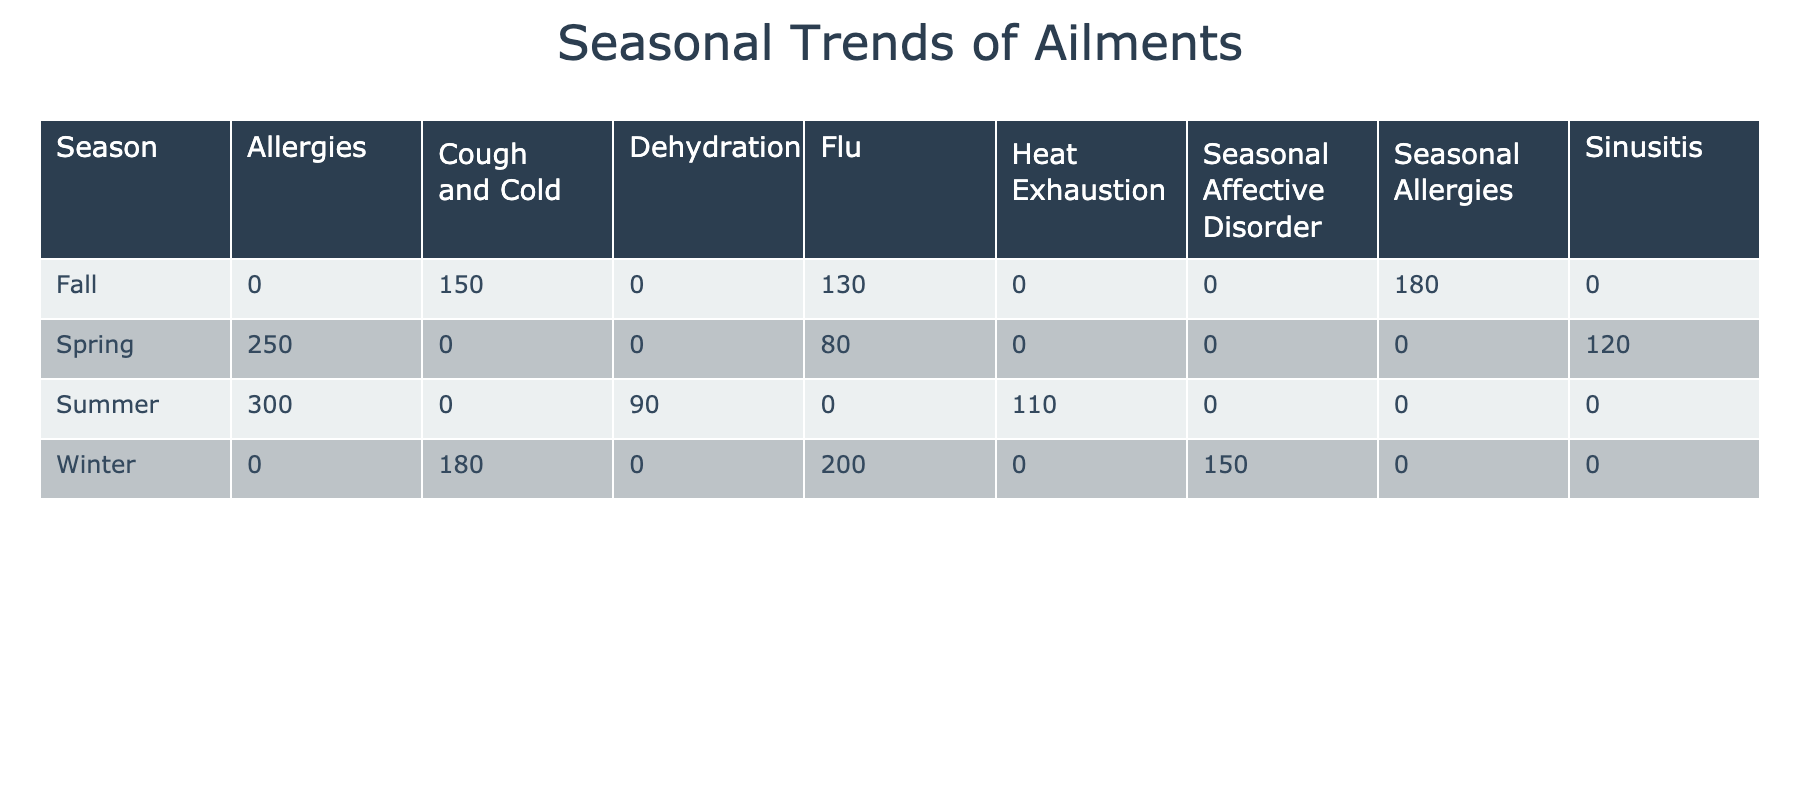What is the total number of reports for allergies in Spring and Summer combined? In Spring, the number of reports for allergies is 250, and in Summer, it is 300. To find the total, we simply add these two values: 250 + 300 = 550.
Answer: 550 Which season has the highest reported cases of flu? Looking at the table, Winter shows 200 reports, Fall has 130 reports, and Spring has 80 reports. Thus, Winter has the highest number of flu cases at 200.
Answer: 200 Did more clients report cough and cold in Winter or Fall? In Winter, there are 180 reports of cough and cold, while in Fall there are 150 reports. Since 180 is greater than 150, more clients reported cough and cold in Winter.
Answer: Yes What is the average number of reports for all ailments reported in Spring? The reports for ailments in Spring are: Allergies (250), Sinusitis (120), and Flu (80). First, sum these values: 250 + 120 + 80 = 450. There are three ailments, so we divide the total by 3: 450 / 3 = 150.
Answer: 150 Is there an ailment that is reported in all seasons? Upon examining the table, flu appears in Winter, Spring, and Fall, but not in Summer. Therefore, there is no single ailment that is reported in all seasons.
Answer: No Which season had the least number of reports for dehydration? Dehydration is only listed in Summer with 90 reports. Since it is the only occurrence, it is also the least number reported for this ailment.
Answer: 90 What do the total reports for Seasonal Allergies compare to the total reports for the Flu across the year? The total for Seasonal Allergies (only reported in Fall) is 180. For Flu, adding all seasons gives Winter (200) + Spring (80) + Fall (130) = 410. Flu has significantly more reports than Seasonal Allergies: 410 versus 180.
Answer: Flu is higher Which ailment has the highest number of reports in Summer? According to the data, in Summer, Allergies account for 300 reports, while other ailments like Dehydration and Heat Exhaustion account for 90 and 110 reports respectively. Thus, Allergies have the highest number of reports in Summer.
Answer: Allergies 